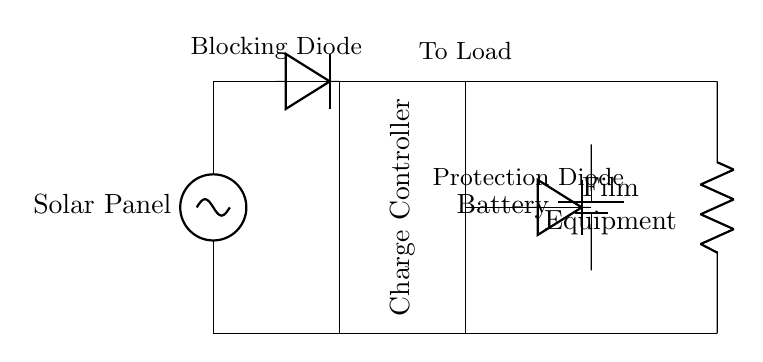What is the type of power source for this system? The power source is a solar panel, which is indicated as the first component in the circuit diagram.
Answer: Solar panel What component regulates the charging to the battery? The component that regulates charging to the battery is a charge controller, which is shown as a rectangle in the circuit diagram.
Answer: Charge controller What is the purpose of the blocking diode in this circuit? The blocking diode prevents reverse current from flowing back from the battery to the solar panel, ensuring that the energy from the solar panel only flows in one direction.
Answer: Prevent reverse current What are the two main loads connected to the circuit? The main loads are the solar panel and the film equipment, which are both indicated in the diagram; the solar panel is the power source, while film equipment is the load consuming power.
Answer: Solar panel and film equipment What is the position of the battery in this circuit? The battery is positioned to the right of the charge controller, and serves as the energy storage component for the system, indicated by its specific symbol.
Answer: Right of charge controller How many diodes are in this circuit? The circuit includes two diodes: a blocking diode and a protection diode as labeled in the diagram, serving different purposes for circuit stability and device protection.
Answer: Two 